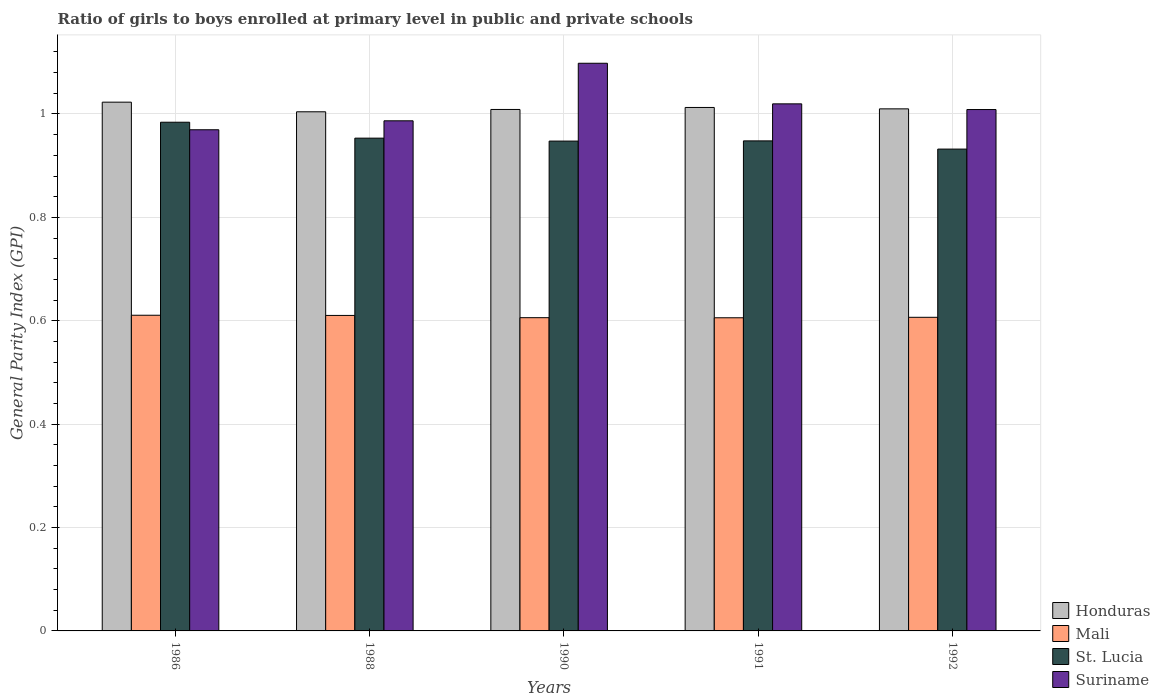How many different coloured bars are there?
Your answer should be compact. 4. How many groups of bars are there?
Offer a very short reply. 5. Are the number of bars per tick equal to the number of legend labels?
Offer a terse response. Yes. How many bars are there on the 5th tick from the left?
Provide a succinct answer. 4. What is the label of the 5th group of bars from the left?
Your response must be concise. 1992. In how many cases, is the number of bars for a given year not equal to the number of legend labels?
Offer a terse response. 0. What is the general parity index in Suriname in 1991?
Offer a terse response. 1.02. Across all years, what is the maximum general parity index in Suriname?
Your answer should be very brief. 1.1. Across all years, what is the minimum general parity index in Honduras?
Make the answer very short. 1. In which year was the general parity index in Honduras minimum?
Offer a very short reply. 1988. What is the total general parity index in St. Lucia in the graph?
Provide a succinct answer. 4.77. What is the difference between the general parity index in Honduras in 1986 and that in 1992?
Offer a terse response. 0.01. What is the difference between the general parity index in Honduras in 1988 and the general parity index in St. Lucia in 1991?
Your answer should be compact. 0.06. What is the average general parity index in Honduras per year?
Provide a short and direct response. 1.01. In the year 1988, what is the difference between the general parity index in Suriname and general parity index in St. Lucia?
Provide a short and direct response. 0.03. What is the ratio of the general parity index in Suriname in 1986 to that in 1992?
Offer a terse response. 0.96. Is the difference between the general parity index in Suriname in 1986 and 1991 greater than the difference between the general parity index in St. Lucia in 1986 and 1991?
Provide a succinct answer. No. What is the difference between the highest and the second highest general parity index in Mali?
Your answer should be very brief. 0. What is the difference between the highest and the lowest general parity index in St. Lucia?
Keep it short and to the point. 0.05. Is the sum of the general parity index in Honduras in 1988 and 1992 greater than the maximum general parity index in St. Lucia across all years?
Your answer should be very brief. Yes. What does the 3rd bar from the left in 1992 represents?
Provide a succinct answer. St. Lucia. What does the 4th bar from the right in 1988 represents?
Provide a succinct answer. Honduras. How many bars are there?
Your response must be concise. 20. Are all the bars in the graph horizontal?
Your answer should be very brief. No. How many years are there in the graph?
Keep it short and to the point. 5. Are the values on the major ticks of Y-axis written in scientific E-notation?
Your answer should be compact. No. Does the graph contain any zero values?
Your response must be concise. No. How many legend labels are there?
Offer a very short reply. 4. What is the title of the graph?
Your answer should be compact. Ratio of girls to boys enrolled at primary level in public and private schools. Does "Chad" appear as one of the legend labels in the graph?
Your answer should be very brief. No. What is the label or title of the X-axis?
Provide a short and direct response. Years. What is the label or title of the Y-axis?
Provide a short and direct response. General Parity Index (GPI). What is the General Parity Index (GPI) in Honduras in 1986?
Your answer should be very brief. 1.02. What is the General Parity Index (GPI) of Mali in 1986?
Ensure brevity in your answer.  0.61. What is the General Parity Index (GPI) in St. Lucia in 1986?
Provide a short and direct response. 0.98. What is the General Parity Index (GPI) of Suriname in 1986?
Give a very brief answer. 0.97. What is the General Parity Index (GPI) of Honduras in 1988?
Keep it short and to the point. 1. What is the General Parity Index (GPI) in Mali in 1988?
Provide a succinct answer. 0.61. What is the General Parity Index (GPI) of St. Lucia in 1988?
Your answer should be very brief. 0.95. What is the General Parity Index (GPI) in Suriname in 1988?
Ensure brevity in your answer.  0.99. What is the General Parity Index (GPI) of Honduras in 1990?
Your answer should be compact. 1.01. What is the General Parity Index (GPI) in Mali in 1990?
Provide a succinct answer. 0.61. What is the General Parity Index (GPI) of St. Lucia in 1990?
Your response must be concise. 0.95. What is the General Parity Index (GPI) of Suriname in 1990?
Make the answer very short. 1.1. What is the General Parity Index (GPI) in Honduras in 1991?
Your answer should be very brief. 1.01. What is the General Parity Index (GPI) of Mali in 1991?
Offer a very short reply. 0.61. What is the General Parity Index (GPI) of St. Lucia in 1991?
Your response must be concise. 0.95. What is the General Parity Index (GPI) in Suriname in 1991?
Make the answer very short. 1.02. What is the General Parity Index (GPI) in Honduras in 1992?
Keep it short and to the point. 1.01. What is the General Parity Index (GPI) in Mali in 1992?
Offer a very short reply. 0.61. What is the General Parity Index (GPI) in St. Lucia in 1992?
Offer a terse response. 0.93. What is the General Parity Index (GPI) of Suriname in 1992?
Make the answer very short. 1.01. Across all years, what is the maximum General Parity Index (GPI) of Honduras?
Your answer should be very brief. 1.02. Across all years, what is the maximum General Parity Index (GPI) in Mali?
Your answer should be very brief. 0.61. Across all years, what is the maximum General Parity Index (GPI) of St. Lucia?
Make the answer very short. 0.98. Across all years, what is the maximum General Parity Index (GPI) in Suriname?
Give a very brief answer. 1.1. Across all years, what is the minimum General Parity Index (GPI) in Honduras?
Your answer should be very brief. 1. Across all years, what is the minimum General Parity Index (GPI) in Mali?
Your answer should be very brief. 0.61. Across all years, what is the minimum General Parity Index (GPI) of St. Lucia?
Make the answer very short. 0.93. Across all years, what is the minimum General Parity Index (GPI) of Suriname?
Offer a terse response. 0.97. What is the total General Parity Index (GPI) of Honduras in the graph?
Offer a very short reply. 5.06. What is the total General Parity Index (GPI) in Mali in the graph?
Offer a very short reply. 3.04. What is the total General Parity Index (GPI) of St. Lucia in the graph?
Make the answer very short. 4.77. What is the total General Parity Index (GPI) of Suriname in the graph?
Your response must be concise. 5.08. What is the difference between the General Parity Index (GPI) in Honduras in 1986 and that in 1988?
Give a very brief answer. 0.02. What is the difference between the General Parity Index (GPI) in St. Lucia in 1986 and that in 1988?
Give a very brief answer. 0.03. What is the difference between the General Parity Index (GPI) of Suriname in 1986 and that in 1988?
Offer a terse response. -0.02. What is the difference between the General Parity Index (GPI) in Honduras in 1986 and that in 1990?
Your response must be concise. 0.01. What is the difference between the General Parity Index (GPI) in Mali in 1986 and that in 1990?
Make the answer very short. 0. What is the difference between the General Parity Index (GPI) in St. Lucia in 1986 and that in 1990?
Give a very brief answer. 0.04. What is the difference between the General Parity Index (GPI) in Suriname in 1986 and that in 1990?
Give a very brief answer. -0.13. What is the difference between the General Parity Index (GPI) of Honduras in 1986 and that in 1991?
Your response must be concise. 0.01. What is the difference between the General Parity Index (GPI) of Mali in 1986 and that in 1991?
Your answer should be very brief. 0. What is the difference between the General Parity Index (GPI) in St. Lucia in 1986 and that in 1991?
Make the answer very short. 0.04. What is the difference between the General Parity Index (GPI) in Suriname in 1986 and that in 1991?
Make the answer very short. -0.05. What is the difference between the General Parity Index (GPI) of Honduras in 1986 and that in 1992?
Give a very brief answer. 0.01. What is the difference between the General Parity Index (GPI) in Mali in 1986 and that in 1992?
Keep it short and to the point. 0. What is the difference between the General Parity Index (GPI) in St. Lucia in 1986 and that in 1992?
Provide a short and direct response. 0.05. What is the difference between the General Parity Index (GPI) in Suriname in 1986 and that in 1992?
Provide a succinct answer. -0.04. What is the difference between the General Parity Index (GPI) of Honduras in 1988 and that in 1990?
Offer a terse response. -0. What is the difference between the General Parity Index (GPI) in Mali in 1988 and that in 1990?
Give a very brief answer. 0. What is the difference between the General Parity Index (GPI) of St. Lucia in 1988 and that in 1990?
Provide a succinct answer. 0.01. What is the difference between the General Parity Index (GPI) in Suriname in 1988 and that in 1990?
Provide a succinct answer. -0.11. What is the difference between the General Parity Index (GPI) in Honduras in 1988 and that in 1991?
Your response must be concise. -0.01. What is the difference between the General Parity Index (GPI) in Mali in 1988 and that in 1991?
Keep it short and to the point. 0. What is the difference between the General Parity Index (GPI) in St. Lucia in 1988 and that in 1991?
Provide a succinct answer. 0.01. What is the difference between the General Parity Index (GPI) of Suriname in 1988 and that in 1991?
Ensure brevity in your answer.  -0.03. What is the difference between the General Parity Index (GPI) in Honduras in 1988 and that in 1992?
Provide a succinct answer. -0.01. What is the difference between the General Parity Index (GPI) in Mali in 1988 and that in 1992?
Offer a terse response. 0. What is the difference between the General Parity Index (GPI) of St. Lucia in 1988 and that in 1992?
Offer a terse response. 0.02. What is the difference between the General Parity Index (GPI) in Suriname in 1988 and that in 1992?
Provide a short and direct response. -0.02. What is the difference between the General Parity Index (GPI) of Honduras in 1990 and that in 1991?
Ensure brevity in your answer.  -0. What is the difference between the General Parity Index (GPI) in Mali in 1990 and that in 1991?
Offer a very short reply. 0. What is the difference between the General Parity Index (GPI) in St. Lucia in 1990 and that in 1991?
Your answer should be compact. -0. What is the difference between the General Parity Index (GPI) in Suriname in 1990 and that in 1991?
Make the answer very short. 0.08. What is the difference between the General Parity Index (GPI) in Honduras in 1990 and that in 1992?
Make the answer very short. -0. What is the difference between the General Parity Index (GPI) in Mali in 1990 and that in 1992?
Provide a succinct answer. -0. What is the difference between the General Parity Index (GPI) of St. Lucia in 1990 and that in 1992?
Make the answer very short. 0.02. What is the difference between the General Parity Index (GPI) of Suriname in 1990 and that in 1992?
Keep it short and to the point. 0.09. What is the difference between the General Parity Index (GPI) in Honduras in 1991 and that in 1992?
Make the answer very short. 0. What is the difference between the General Parity Index (GPI) in Mali in 1991 and that in 1992?
Offer a terse response. -0. What is the difference between the General Parity Index (GPI) of St. Lucia in 1991 and that in 1992?
Provide a succinct answer. 0.02. What is the difference between the General Parity Index (GPI) in Suriname in 1991 and that in 1992?
Your response must be concise. 0.01. What is the difference between the General Parity Index (GPI) in Honduras in 1986 and the General Parity Index (GPI) in Mali in 1988?
Offer a very short reply. 0.41. What is the difference between the General Parity Index (GPI) in Honduras in 1986 and the General Parity Index (GPI) in St. Lucia in 1988?
Provide a succinct answer. 0.07. What is the difference between the General Parity Index (GPI) of Honduras in 1986 and the General Parity Index (GPI) of Suriname in 1988?
Ensure brevity in your answer.  0.04. What is the difference between the General Parity Index (GPI) in Mali in 1986 and the General Parity Index (GPI) in St. Lucia in 1988?
Provide a succinct answer. -0.34. What is the difference between the General Parity Index (GPI) of Mali in 1986 and the General Parity Index (GPI) of Suriname in 1988?
Offer a terse response. -0.38. What is the difference between the General Parity Index (GPI) of St. Lucia in 1986 and the General Parity Index (GPI) of Suriname in 1988?
Ensure brevity in your answer.  -0. What is the difference between the General Parity Index (GPI) in Honduras in 1986 and the General Parity Index (GPI) in Mali in 1990?
Offer a terse response. 0.42. What is the difference between the General Parity Index (GPI) in Honduras in 1986 and the General Parity Index (GPI) in St. Lucia in 1990?
Keep it short and to the point. 0.08. What is the difference between the General Parity Index (GPI) in Honduras in 1986 and the General Parity Index (GPI) in Suriname in 1990?
Your answer should be very brief. -0.08. What is the difference between the General Parity Index (GPI) in Mali in 1986 and the General Parity Index (GPI) in St. Lucia in 1990?
Provide a succinct answer. -0.34. What is the difference between the General Parity Index (GPI) of Mali in 1986 and the General Parity Index (GPI) of Suriname in 1990?
Offer a very short reply. -0.49. What is the difference between the General Parity Index (GPI) of St. Lucia in 1986 and the General Parity Index (GPI) of Suriname in 1990?
Your answer should be very brief. -0.11. What is the difference between the General Parity Index (GPI) of Honduras in 1986 and the General Parity Index (GPI) of Mali in 1991?
Offer a very short reply. 0.42. What is the difference between the General Parity Index (GPI) of Honduras in 1986 and the General Parity Index (GPI) of St. Lucia in 1991?
Your response must be concise. 0.07. What is the difference between the General Parity Index (GPI) of Honduras in 1986 and the General Parity Index (GPI) of Suriname in 1991?
Your answer should be compact. 0. What is the difference between the General Parity Index (GPI) in Mali in 1986 and the General Parity Index (GPI) in St. Lucia in 1991?
Keep it short and to the point. -0.34. What is the difference between the General Parity Index (GPI) in Mali in 1986 and the General Parity Index (GPI) in Suriname in 1991?
Provide a short and direct response. -0.41. What is the difference between the General Parity Index (GPI) of St. Lucia in 1986 and the General Parity Index (GPI) of Suriname in 1991?
Provide a succinct answer. -0.04. What is the difference between the General Parity Index (GPI) of Honduras in 1986 and the General Parity Index (GPI) of Mali in 1992?
Provide a short and direct response. 0.42. What is the difference between the General Parity Index (GPI) of Honduras in 1986 and the General Parity Index (GPI) of St. Lucia in 1992?
Make the answer very short. 0.09. What is the difference between the General Parity Index (GPI) of Honduras in 1986 and the General Parity Index (GPI) of Suriname in 1992?
Offer a very short reply. 0.01. What is the difference between the General Parity Index (GPI) of Mali in 1986 and the General Parity Index (GPI) of St. Lucia in 1992?
Offer a terse response. -0.32. What is the difference between the General Parity Index (GPI) of Mali in 1986 and the General Parity Index (GPI) of Suriname in 1992?
Give a very brief answer. -0.4. What is the difference between the General Parity Index (GPI) in St. Lucia in 1986 and the General Parity Index (GPI) in Suriname in 1992?
Offer a very short reply. -0.02. What is the difference between the General Parity Index (GPI) in Honduras in 1988 and the General Parity Index (GPI) in Mali in 1990?
Offer a terse response. 0.4. What is the difference between the General Parity Index (GPI) in Honduras in 1988 and the General Parity Index (GPI) in St. Lucia in 1990?
Your answer should be compact. 0.06. What is the difference between the General Parity Index (GPI) in Honduras in 1988 and the General Parity Index (GPI) in Suriname in 1990?
Provide a short and direct response. -0.09. What is the difference between the General Parity Index (GPI) in Mali in 1988 and the General Parity Index (GPI) in St. Lucia in 1990?
Provide a succinct answer. -0.34. What is the difference between the General Parity Index (GPI) in Mali in 1988 and the General Parity Index (GPI) in Suriname in 1990?
Offer a terse response. -0.49. What is the difference between the General Parity Index (GPI) in St. Lucia in 1988 and the General Parity Index (GPI) in Suriname in 1990?
Your answer should be very brief. -0.14. What is the difference between the General Parity Index (GPI) in Honduras in 1988 and the General Parity Index (GPI) in Mali in 1991?
Make the answer very short. 0.4. What is the difference between the General Parity Index (GPI) in Honduras in 1988 and the General Parity Index (GPI) in St. Lucia in 1991?
Keep it short and to the point. 0.06. What is the difference between the General Parity Index (GPI) of Honduras in 1988 and the General Parity Index (GPI) of Suriname in 1991?
Your answer should be compact. -0.02. What is the difference between the General Parity Index (GPI) in Mali in 1988 and the General Parity Index (GPI) in St. Lucia in 1991?
Offer a terse response. -0.34. What is the difference between the General Parity Index (GPI) of Mali in 1988 and the General Parity Index (GPI) of Suriname in 1991?
Your answer should be compact. -0.41. What is the difference between the General Parity Index (GPI) in St. Lucia in 1988 and the General Parity Index (GPI) in Suriname in 1991?
Your response must be concise. -0.07. What is the difference between the General Parity Index (GPI) in Honduras in 1988 and the General Parity Index (GPI) in Mali in 1992?
Offer a very short reply. 0.4. What is the difference between the General Parity Index (GPI) in Honduras in 1988 and the General Parity Index (GPI) in St. Lucia in 1992?
Offer a terse response. 0.07. What is the difference between the General Parity Index (GPI) in Honduras in 1988 and the General Parity Index (GPI) in Suriname in 1992?
Make the answer very short. -0. What is the difference between the General Parity Index (GPI) in Mali in 1988 and the General Parity Index (GPI) in St. Lucia in 1992?
Your answer should be very brief. -0.32. What is the difference between the General Parity Index (GPI) in Mali in 1988 and the General Parity Index (GPI) in Suriname in 1992?
Give a very brief answer. -0.4. What is the difference between the General Parity Index (GPI) in St. Lucia in 1988 and the General Parity Index (GPI) in Suriname in 1992?
Give a very brief answer. -0.06. What is the difference between the General Parity Index (GPI) of Honduras in 1990 and the General Parity Index (GPI) of Mali in 1991?
Provide a succinct answer. 0.4. What is the difference between the General Parity Index (GPI) in Honduras in 1990 and the General Parity Index (GPI) in St. Lucia in 1991?
Provide a succinct answer. 0.06. What is the difference between the General Parity Index (GPI) in Honduras in 1990 and the General Parity Index (GPI) in Suriname in 1991?
Make the answer very short. -0.01. What is the difference between the General Parity Index (GPI) of Mali in 1990 and the General Parity Index (GPI) of St. Lucia in 1991?
Provide a short and direct response. -0.34. What is the difference between the General Parity Index (GPI) of Mali in 1990 and the General Parity Index (GPI) of Suriname in 1991?
Make the answer very short. -0.41. What is the difference between the General Parity Index (GPI) in St. Lucia in 1990 and the General Parity Index (GPI) in Suriname in 1991?
Give a very brief answer. -0.07. What is the difference between the General Parity Index (GPI) in Honduras in 1990 and the General Parity Index (GPI) in Mali in 1992?
Offer a very short reply. 0.4. What is the difference between the General Parity Index (GPI) of Honduras in 1990 and the General Parity Index (GPI) of St. Lucia in 1992?
Provide a succinct answer. 0.08. What is the difference between the General Parity Index (GPI) in Honduras in 1990 and the General Parity Index (GPI) in Suriname in 1992?
Offer a very short reply. 0. What is the difference between the General Parity Index (GPI) of Mali in 1990 and the General Parity Index (GPI) of St. Lucia in 1992?
Give a very brief answer. -0.33. What is the difference between the General Parity Index (GPI) in Mali in 1990 and the General Parity Index (GPI) in Suriname in 1992?
Your response must be concise. -0.4. What is the difference between the General Parity Index (GPI) of St. Lucia in 1990 and the General Parity Index (GPI) of Suriname in 1992?
Your response must be concise. -0.06. What is the difference between the General Parity Index (GPI) in Honduras in 1991 and the General Parity Index (GPI) in Mali in 1992?
Your response must be concise. 0.41. What is the difference between the General Parity Index (GPI) of Honduras in 1991 and the General Parity Index (GPI) of St. Lucia in 1992?
Your answer should be compact. 0.08. What is the difference between the General Parity Index (GPI) in Honduras in 1991 and the General Parity Index (GPI) in Suriname in 1992?
Make the answer very short. 0. What is the difference between the General Parity Index (GPI) in Mali in 1991 and the General Parity Index (GPI) in St. Lucia in 1992?
Your response must be concise. -0.33. What is the difference between the General Parity Index (GPI) of Mali in 1991 and the General Parity Index (GPI) of Suriname in 1992?
Provide a succinct answer. -0.4. What is the difference between the General Parity Index (GPI) in St. Lucia in 1991 and the General Parity Index (GPI) in Suriname in 1992?
Provide a short and direct response. -0.06. What is the average General Parity Index (GPI) in Honduras per year?
Your response must be concise. 1.01. What is the average General Parity Index (GPI) of Mali per year?
Ensure brevity in your answer.  0.61. What is the average General Parity Index (GPI) in St. Lucia per year?
Ensure brevity in your answer.  0.95. What is the average General Parity Index (GPI) of Suriname per year?
Make the answer very short. 1.02. In the year 1986, what is the difference between the General Parity Index (GPI) of Honduras and General Parity Index (GPI) of Mali?
Your answer should be very brief. 0.41. In the year 1986, what is the difference between the General Parity Index (GPI) of Honduras and General Parity Index (GPI) of St. Lucia?
Your answer should be very brief. 0.04. In the year 1986, what is the difference between the General Parity Index (GPI) in Honduras and General Parity Index (GPI) in Suriname?
Your answer should be very brief. 0.05. In the year 1986, what is the difference between the General Parity Index (GPI) in Mali and General Parity Index (GPI) in St. Lucia?
Offer a very short reply. -0.37. In the year 1986, what is the difference between the General Parity Index (GPI) in Mali and General Parity Index (GPI) in Suriname?
Your response must be concise. -0.36. In the year 1986, what is the difference between the General Parity Index (GPI) in St. Lucia and General Parity Index (GPI) in Suriname?
Your response must be concise. 0.01. In the year 1988, what is the difference between the General Parity Index (GPI) in Honduras and General Parity Index (GPI) in Mali?
Make the answer very short. 0.39. In the year 1988, what is the difference between the General Parity Index (GPI) of Honduras and General Parity Index (GPI) of St. Lucia?
Offer a very short reply. 0.05. In the year 1988, what is the difference between the General Parity Index (GPI) in Honduras and General Parity Index (GPI) in Suriname?
Your answer should be compact. 0.02. In the year 1988, what is the difference between the General Parity Index (GPI) in Mali and General Parity Index (GPI) in St. Lucia?
Provide a short and direct response. -0.34. In the year 1988, what is the difference between the General Parity Index (GPI) of Mali and General Parity Index (GPI) of Suriname?
Your answer should be compact. -0.38. In the year 1988, what is the difference between the General Parity Index (GPI) of St. Lucia and General Parity Index (GPI) of Suriname?
Your answer should be very brief. -0.03. In the year 1990, what is the difference between the General Parity Index (GPI) in Honduras and General Parity Index (GPI) in Mali?
Make the answer very short. 0.4. In the year 1990, what is the difference between the General Parity Index (GPI) of Honduras and General Parity Index (GPI) of St. Lucia?
Offer a terse response. 0.06. In the year 1990, what is the difference between the General Parity Index (GPI) in Honduras and General Parity Index (GPI) in Suriname?
Make the answer very short. -0.09. In the year 1990, what is the difference between the General Parity Index (GPI) in Mali and General Parity Index (GPI) in St. Lucia?
Offer a terse response. -0.34. In the year 1990, what is the difference between the General Parity Index (GPI) in Mali and General Parity Index (GPI) in Suriname?
Make the answer very short. -0.49. In the year 1990, what is the difference between the General Parity Index (GPI) of St. Lucia and General Parity Index (GPI) of Suriname?
Provide a short and direct response. -0.15. In the year 1991, what is the difference between the General Parity Index (GPI) of Honduras and General Parity Index (GPI) of Mali?
Provide a succinct answer. 0.41. In the year 1991, what is the difference between the General Parity Index (GPI) of Honduras and General Parity Index (GPI) of St. Lucia?
Keep it short and to the point. 0.06. In the year 1991, what is the difference between the General Parity Index (GPI) in Honduras and General Parity Index (GPI) in Suriname?
Offer a very short reply. -0.01. In the year 1991, what is the difference between the General Parity Index (GPI) in Mali and General Parity Index (GPI) in St. Lucia?
Keep it short and to the point. -0.34. In the year 1991, what is the difference between the General Parity Index (GPI) in Mali and General Parity Index (GPI) in Suriname?
Ensure brevity in your answer.  -0.41. In the year 1991, what is the difference between the General Parity Index (GPI) in St. Lucia and General Parity Index (GPI) in Suriname?
Make the answer very short. -0.07. In the year 1992, what is the difference between the General Parity Index (GPI) in Honduras and General Parity Index (GPI) in Mali?
Keep it short and to the point. 0.4. In the year 1992, what is the difference between the General Parity Index (GPI) of Honduras and General Parity Index (GPI) of St. Lucia?
Ensure brevity in your answer.  0.08. In the year 1992, what is the difference between the General Parity Index (GPI) in Honduras and General Parity Index (GPI) in Suriname?
Ensure brevity in your answer.  0. In the year 1992, what is the difference between the General Parity Index (GPI) in Mali and General Parity Index (GPI) in St. Lucia?
Make the answer very short. -0.33. In the year 1992, what is the difference between the General Parity Index (GPI) in Mali and General Parity Index (GPI) in Suriname?
Your answer should be compact. -0.4. In the year 1992, what is the difference between the General Parity Index (GPI) of St. Lucia and General Parity Index (GPI) of Suriname?
Offer a very short reply. -0.08. What is the ratio of the General Parity Index (GPI) in Honduras in 1986 to that in 1988?
Ensure brevity in your answer.  1.02. What is the ratio of the General Parity Index (GPI) in Mali in 1986 to that in 1988?
Your response must be concise. 1. What is the ratio of the General Parity Index (GPI) of St. Lucia in 1986 to that in 1988?
Offer a terse response. 1.03. What is the ratio of the General Parity Index (GPI) of Suriname in 1986 to that in 1988?
Your response must be concise. 0.98. What is the ratio of the General Parity Index (GPI) in Suriname in 1986 to that in 1990?
Give a very brief answer. 0.88. What is the ratio of the General Parity Index (GPI) of Mali in 1986 to that in 1991?
Your answer should be very brief. 1.01. What is the ratio of the General Parity Index (GPI) in St. Lucia in 1986 to that in 1991?
Provide a short and direct response. 1.04. What is the ratio of the General Parity Index (GPI) in Suriname in 1986 to that in 1991?
Keep it short and to the point. 0.95. What is the ratio of the General Parity Index (GPI) in Honduras in 1986 to that in 1992?
Give a very brief answer. 1.01. What is the ratio of the General Parity Index (GPI) in Mali in 1986 to that in 1992?
Ensure brevity in your answer.  1.01. What is the ratio of the General Parity Index (GPI) in St. Lucia in 1986 to that in 1992?
Offer a terse response. 1.06. What is the ratio of the General Parity Index (GPI) in Suriname in 1986 to that in 1992?
Keep it short and to the point. 0.96. What is the ratio of the General Parity Index (GPI) in St. Lucia in 1988 to that in 1990?
Your answer should be very brief. 1.01. What is the ratio of the General Parity Index (GPI) of Suriname in 1988 to that in 1990?
Provide a succinct answer. 0.9. What is the ratio of the General Parity Index (GPI) in Mali in 1988 to that in 1991?
Provide a succinct answer. 1.01. What is the ratio of the General Parity Index (GPI) in St. Lucia in 1988 to that in 1991?
Offer a terse response. 1.01. What is the ratio of the General Parity Index (GPI) in Suriname in 1988 to that in 1991?
Provide a succinct answer. 0.97. What is the ratio of the General Parity Index (GPI) of Honduras in 1988 to that in 1992?
Provide a succinct answer. 0.99. What is the ratio of the General Parity Index (GPI) of Mali in 1988 to that in 1992?
Offer a terse response. 1.01. What is the ratio of the General Parity Index (GPI) of St. Lucia in 1988 to that in 1992?
Your answer should be very brief. 1.02. What is the ratio of the General Parity Index (GPI) in Suriname in 1988 to that in 1992?
Your answer should be compact. 0.98. What is the ratio of the General Parity Index (GPI) in Honduras in 1990 to that in 1991?
Your answer should be compact. 1. What is the ratio of the General Parity Index (GPI) of Suriname in 1990 to that in 1991?
Provide a succinct answer. 1.08. What is the ratio of the General Parity Index (GPI) of Honduras in 1990 to that in 1992?
Ensure brevity in your answer.  1. What is the ratio of the General Parity Index (GPI) of Mali in 1990 to that in 1992?
Offer a very short reply. 1. What is the ratio of the General Parity Index (GPI) in St. Lucia in 1990 to that in 1992?
Offer a very short reply. 1.02. What is the ratio of the General Parity Index (GPI) in Suriname in 1990 to that in 1992?
Keep it short and to the point. 1.09. What is the ratio of the General Parity Index (GPI) of Honduras in 1991 to that in 1992?
Offer a very short reply. 1. What is the ratio of the General Parity Index (GPI) in Suriname in 1991 to that in 1992?
Ensure brevity in your answer.  1.01. What is the difference between the highest and the second highest General Parity Index (GPI) in Honduras?
Offer a very short reply. 0.01. What is the difference between the highest and the second highest General Parity Index (GPI) in St. Lucia?
Make the answer very short. 0.03. What is the difference between the highest and the second highest General Parity Index (GPI) in Suriname?
Your answer should be compact. 0.08. What is the difference between the highest and the lowest General Parity Index (GPI) of Honduras?
Provide a short and direct response. 0.02. What is the difference between the highest and the lowest General Parity Index (GPI) of Mali?
Offer a very short reply. 0. What is the difference between the highest and the lowest General Parity Index (GPI) in St. Lucia?
Give a very brief answer. 0.05. What is the difference between the highest and the lowest General Parity Index (GPI) of Suriname?
Give a very brief answer. 0.13. 